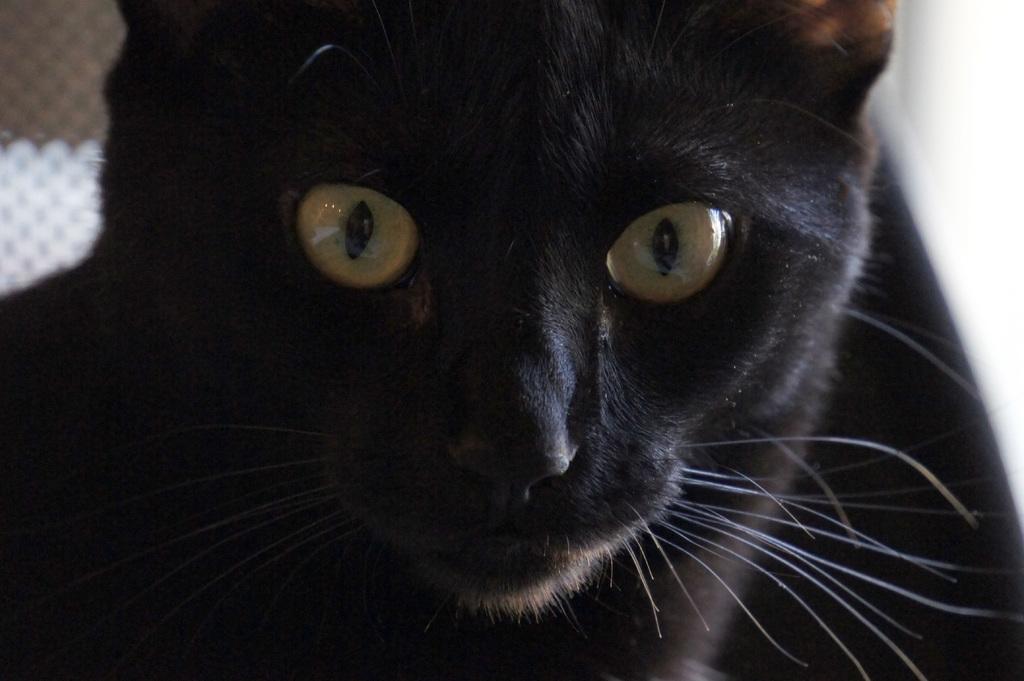Could you give a brief overview of what you see in this image? In the image we can see there is a black colour cat. 